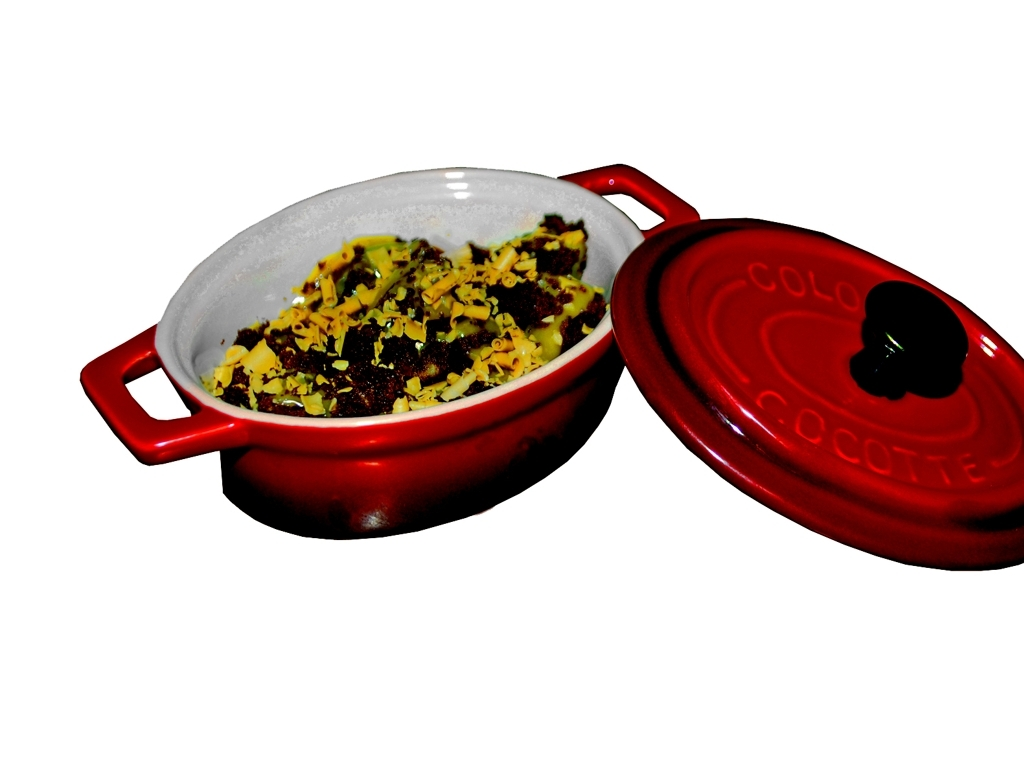What type of dish is shown in the image? The dish appears to be a casserole or similar baked dish, featuring a combination of ingredients, possibly including cheese and herbs, given the yellow and green colors sprinkled on top. 